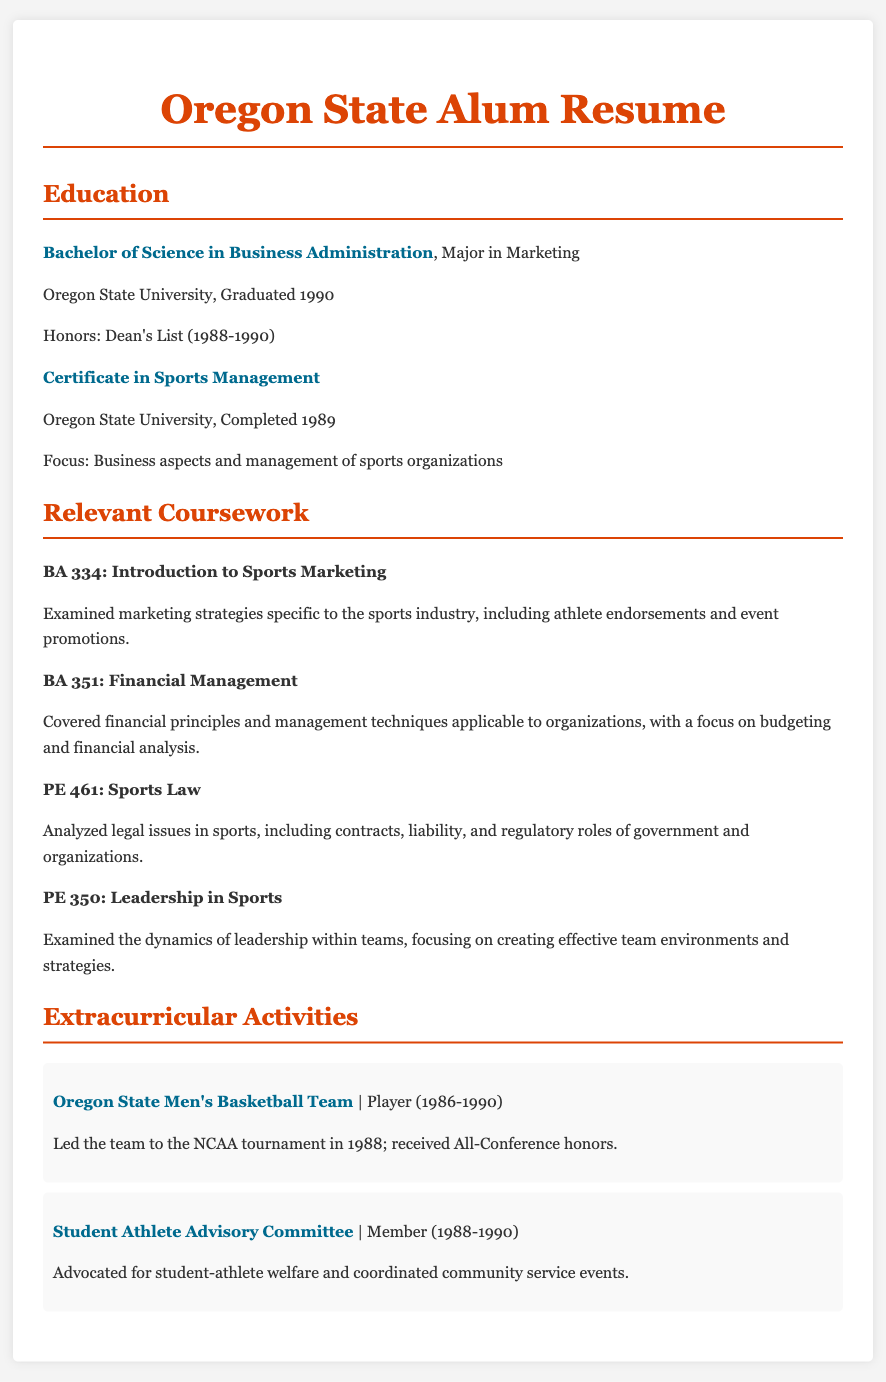What degree was earned from Oregon State University? The document states that a Bachelor of Science in Business Administration was earned.
Answer: Bachelor of Science in Business Administration What was the major of the degree earned? The document specifies that the major was Marketing.
Answer: Major in Marketing When did the degree get completed? The document indicates that the degree was completed in 1990.
Answer: Graduated 1990 Which course focused on legal issues in sports? The course that focused on legal issues is PE 461: Sports Law.
Answer: PE 461: Sports Law How many courses are listed under Relevant Coursework? There are four courses listed under Relevant Coursework in the document.
Answer: Four What honors were received during the studies? The document mentions receiving Dean's List honors.
Answer: Dean's List Which extracurricular activity involved advocating for student-athlete welfare? The document states that the Student Athlete Advisory Committee involved advocating for student-athlete welfare.
Answer: Student Athlete Advisory Committee What year did the Oregon State Men's Basketball Team participate in the NCAA tournament? The document highlights that the team participated in the NCAA tournament in 1988.
Answer: 1988 What certificate was completed alongside the degree? The document specifies that a Certificate in Sports Management was completed.
Answer: Certificate in Sports Management 